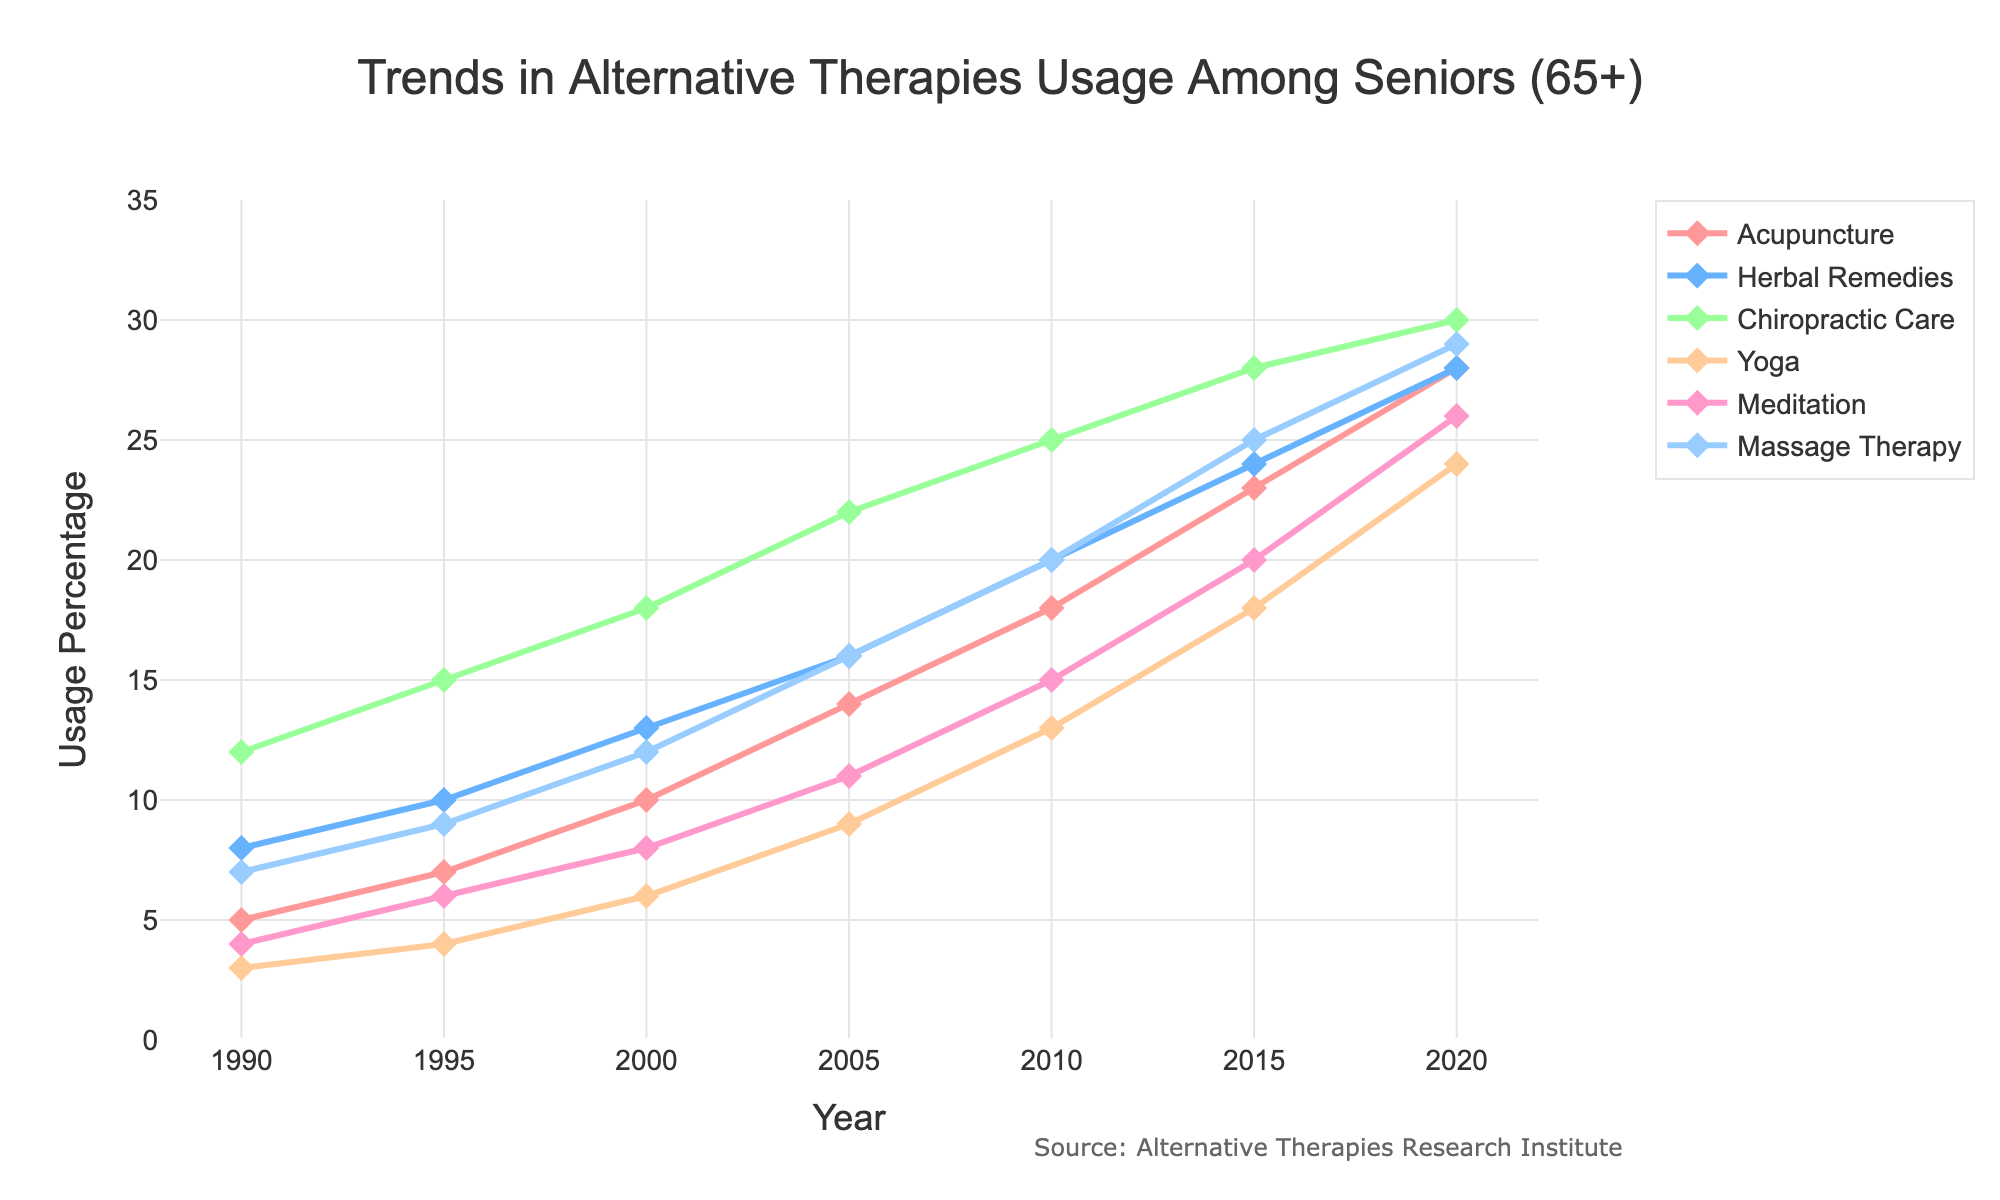Which alternative therapy saw the greatest increase in usage from 1990 to 2020? To find which therapy saw the greatest increase, subtract the 1990 value from the 2020 value for each type. Acupuncture increased from 5% to 28% (23% increase), Herbal Remedies from 8% to 28% (20% increase), Chiropractic Care from 12% to 30% (18% increase), Yoga from 3% to 24% (21% increase), Meditation from 4% to 26% (22% increase), and Massage Therapy from 7% to 29% (22% increase). Acupuncture had the largest increase of 23%.
Answer: Acupuncture Which therapy had the highest usage rate in 2020? Look at the values of each therapy for the year 2020. Acupuncture: 28%, Herbal Remedies: 28%, Chiropractic Care: 30%, Yoga: 24%, Meditation: 26%, Massage Therapy: 29%. Chiropractic Care has the highest usage rate.
Answer: Chiropractic Care Compare the usage of Acupuncture and Yoga in 2010. Which one was more popular? Check the values for Acupuncture and Yoga in 2010. Acupuncture usage was at 18%, and Yoga usage was at 13%. Acupuncture was more popular in 2010.
Answer: Acupuncture How did the usage of Meditation change between 1990 and 2015? Look at the Meditation percentages in 1990 and 2015. In 1990, the value was 4%, and in 2015, it was 20%. The change from 4% to 20% represents an increase of 16 percentage points.
Answer: Increased by 16 percentage points Which therapy had a steady increase in usage and reached exactly 28% by 2020? Determine which therapy shows a consistent rise over the years and reaches 28% in the year 2020. Both Acupuncture and Herbal Remedies meet this criterion, rising steadily to reach 28% by 2020.
Answer: Acupuncture and Herbal Remedies By how much did the usage of Chiropractic Care and Massage Therapy differ in 2000? Look at the values for Chiropractic Care and Massage Therapy in 2000. Chiropractic Care was at 18%, and Massage Therapy was at 12%. The difference is 18% - 12% = 6%.
Answer: 6% Which therapy had the least usage in 1990 and how much did it increase by 2020? Find the smallest value in 1990 and compare it to its value in 2020. Yoga had the least usage at 3% in 1990. By 2020, Yoga usage increased to 24%. The increase is 24% - 3% = 21%.
Answer: Yoga, increased by 21% What was the average usage of Herbal Remedies across all the given years? Sum the Herbal Remedies usage percentages for all years (8 + 10 + 13 + 16 + 20 + 24 + 28) and divide by the number of years (7). The total is 119, and the average is 119 / 7 ≈ 17%.
Answer: 17% Compare the growth trends of Acupuncture and Herbal Remedies from 1990 to 2020. Which one had a higher average yearly increase? Calculate the increase for each therapy from 1990 to 2020. Acupuncture: 28% - 5% = 23%; Herbal Remedies: 28% - 8% = 20%. The number of years is 30. Average yearly increase for Acupuncture: 23/30 ≈ 0.77%; for Herbal Remedies: 20/30 ≈ 0.67%. Acupuncture had a higher average yearly increase.
Answer: Acupuncture By what percentage did Yoga usage increase from 2005 to 2020? Look at the Yoga percentages for 2005 and 2020. In 2005, it was 9% and in 2020, it rose to 24%. The increase is 24% - 9% = 15%. The percentage increase relative to 2005 is (15/9) * 100% ≈ 166.67%.
Answer: 166.67% 